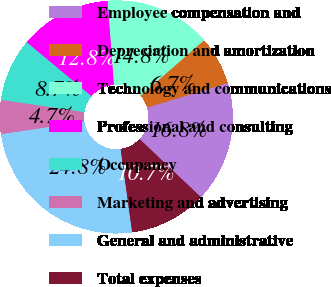<chart> <loc_0><loc_0><loc_500><loc_500><pie_chart><fcel>Employee compensation and<fcel>Depreciation and amortization<fcel>Technology and communications<fcel>Professional and consulting<fcel>Occupancy<fcel>Marketing and advertising<fcel>General and administrative<fcel>Total expenses<nl><fcel>16.77%<fcel>6.73%<fcel>14.76%<fcel>12.75%<fcel>8.73%<fcel>4.72%<fcel>24.8%<fcel>10.74%<nl></chart> 